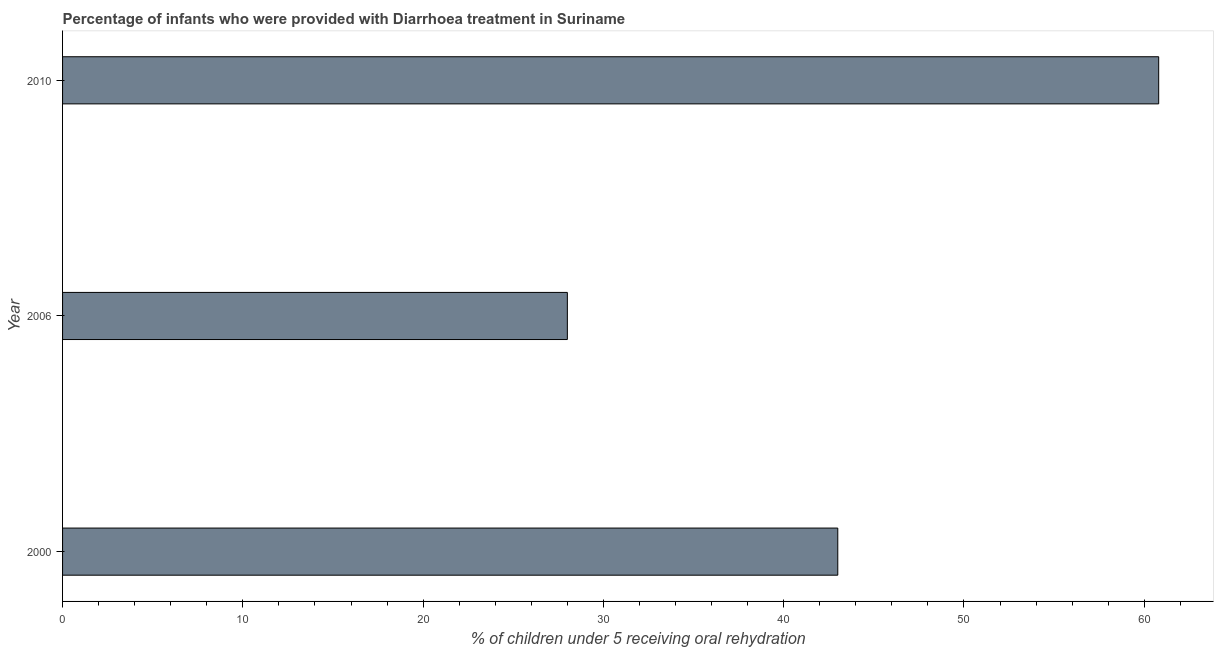What is the title of the graph?
Provide a succinct answer. Percentage of infants who were provided with Diarrhoea treatment in Suriname. What is the label or title of the X-axis?
Offer a terse response. % of children under 5 receiving oral rehydration. What is the label or title of the Y-axis?
Offer a very short reply. Year. What is the percentage of children who were provided with treatment diarrhoea in 2000?
Provide a succinct answer. 43. Across all years, what is the maximum percentage of children who were provided with treatment diarrhoea?
Provide a succinct answer. 60.8. Across all years, what is the minimum percentage of children who were provided with treatment diarrhoea?
Make the answer very short. 28. In which year was the percentage of children who were provided with treatment diarrhoea maximum?
Your response must be concise. 2010. What is the sum of the percentage of children who were provided with treatment diarrhoea?
Give a very brief answer. 131.8. What is the difference between the percentage of children who were provided with treatment diarrhoea in 2000 and 2010?
Your response must be concise. -17.8. What is the average percentage of children who were provided with treatment diarrhoea per year?
Make the answer very short. 43.93. What is the median percentage of children who were provided with treatment diarrhoea?
Your answer should be compact. 43. In how many years, is the percentage of children who were provided with treatment diarrhoea greater than 60 %?
Your response must be concise. 1. Do a majority of the years between 2000 and 2010 (inclusive) have percentage of children who were provided with treatment diarrhoea greater than 56 %?
Offer a very short reply. No. What is the ratio of the percentage of children who were provided with treatment diarrhoea in 2006 to that in 2010?
Your answer should be compact. 0.46. Is the percentage of children who were provided with treatment diarrhoea in 2000 less than that in 2006?
Ensure brevity in your answer.  No. Is the difference between the percentage of children who were provided with treatment diarrhoea in 2006 and 2010 greater than the difference between any two years?
Offer a terse response. Yes. Is the sum of the percentage of children who were provided with treatment diarrhoea in 2000 and 2006 greater than the maximum percentage of children who were provided with treatment diarrhoea across all years?
Your answer should be compact. Yes. What is the difference between the highest and the lowest percentage of children who were provided with treatment diarrhoea?
Give a very brief answer. 32.8. In how many years, is the percentage of children who were provided with treatment diarrhoea greater than the average percentage of children who were provided with treatment diarrhoea taken over all years?
Your response must be concise. 1. Are all the bars in the graph horizontal?
Provide a succinct answer. Yes. Are the values on the major ticks of X-axis written in scientific E-notation?
Your answer should be very brief. No. What is the % of children under 5 receiving oral rehydration in 2006?
Provide a succinct answer. 28. What is the % of children under 5 receiving oral rehydration in 2010?
Make the answer very short. 60.8. What is the difference between the % of children under 5 receiving oral rehydration in 2000 and 2010?
Make the answer very short. -17.8. What is the difference between the % of children under 5 receiving oral rehydration in 2006 and 2010?
Keep it short and to the point. -32.8. What is the ratio of the % of children under 5 receiving oral rehydration in 2000 to that in 2006?
Make the answer very short. 1.54. What is the ratio of the % of children under 5 receiving oral rehydration in 2000 to that in 2010?
Offer a very short reply. 0.71. What is the ratio of the % of children under 5 receiving oral rehydration in 2006 to that in 2010?
Your response must be concise. 0.46. 